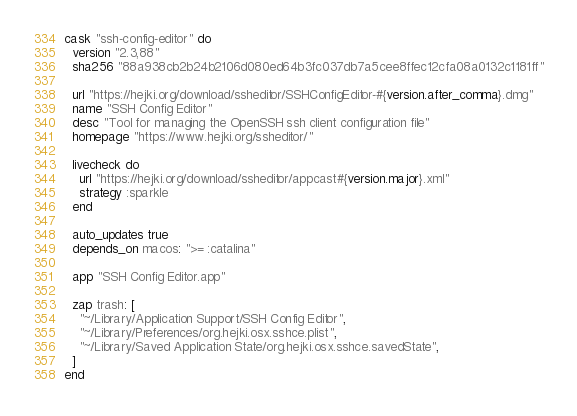Convert code to text. <code><loc_0><loc_0><loc_500><loc_500><_Ruby_>cask "ssh-config-editor" do
  version "2.3,88"
  sha256 "88a938cb2b24b2106d080ed64b3fc037db7a5cee8ffec12cfa08a0132c1181ff"

  url "https://hejki.org/download/ssheditor/SSHConfigEditor-#{version.after_comma}.dmg"
  name "SSH Config Editor"
  desc "Tool for managing the OpenSSH ssh client configuration file"
  homepage "https://www.hejki.org/ssheditor/"

  livecheck do
    url "https://hejki.org/download/ssheditor/appcast#{version.major}.xml"
    strategy :sparkle
  end

  auto_updates true
  depends_on macos: ">= :catalina"

  app "SSH Config Editor.app"

  zap trash: [
    "~/Library/Application Support/SSH Config Editor",
    "~/Library/Preferences/org.hejki.osx.sshce.plist",
    "~/Library/Saved Application State/org.hejki.osx.sshce.savedState",
  ]
end
</code> 